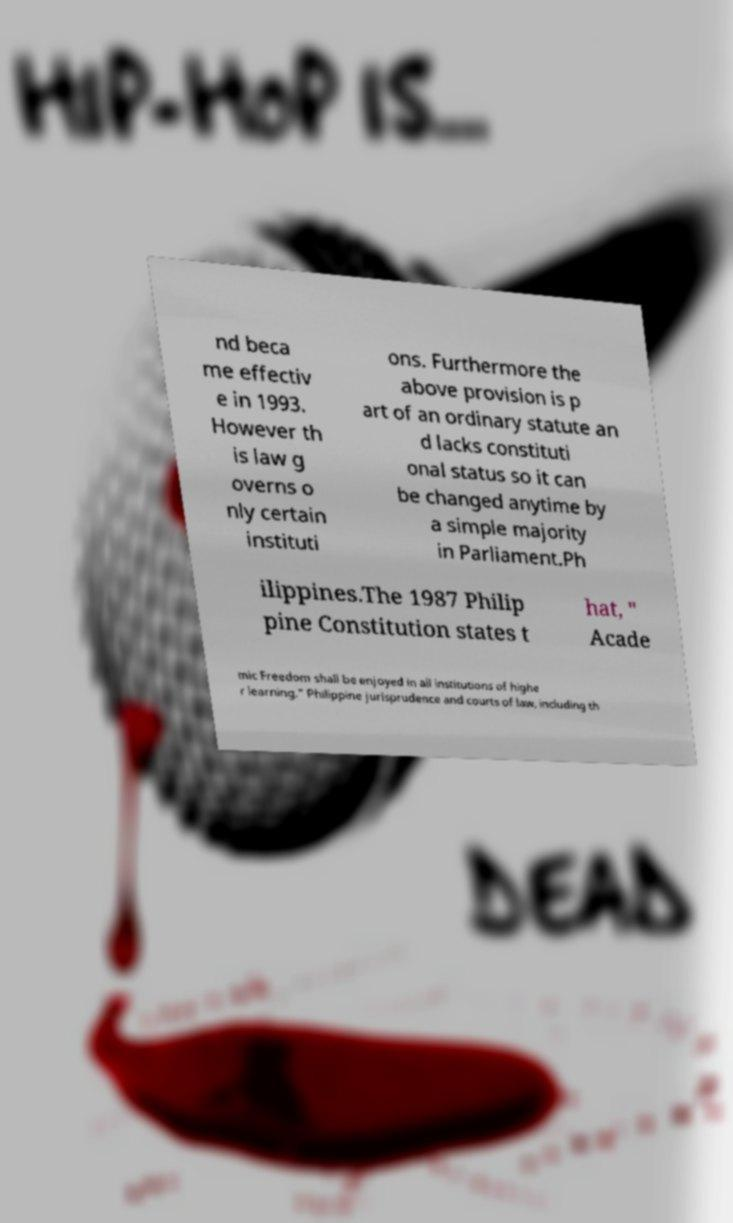Please identify and transcribe the text found in this image. nd beca me effectiv e in 1993. However th is law g overns o nly certain instituti ons. Furthermore the above provision is p art of an ordinary statute an d lacks constituti onal status so it can be changed anytime by a simple majority in Parliament.Ph ilippines.The 1987 Philip pine Constitution states t hat, " Acade mic Freedom shall be enjoyed in all institutions of highe r learning." Philippine jurisprudence and courts of law, including th 